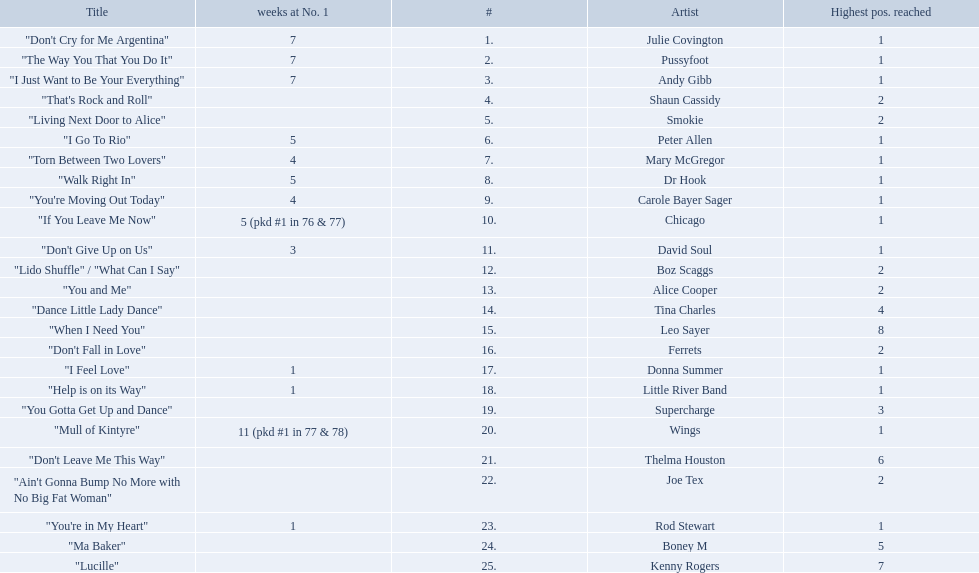Who had the one of the least weeks at number one? Rod Stewart. Parse the full table. {'header': ['Title', 'weeks at No. 1', '#', 'Artist', 'Highest pos. reached'], 'rows': [['"Don\'t Cry for Me Argentina"', '7', '1.', 'Julie Covington', '1'], ['"The Way You That You Do It"', '7', '2.', 'Pussyfoot', '1'], ['"I Just Want to Be Your Everything"', '7', '3.', 'Andy Gibb', '1'], ['"That\'s Rock and Roll"', '', '4.', 'Shaun Cassidy', '2'], ['"Living Next Door to Alice"', '', '5.', 'Smokie', '2'], ['"I Go To Rio"', '5', '6.', 'Peter Allen', '1'], ['"Torn Between Two Lovers"', '4', '7.', 'Mary McGregor', '1'], ['"Walk Right In"', '5', '8.', 'Dr Hook', '1'], ['"You\'re Moving Out Today"', '4', '9.', 'Carole Bayer Sager', '1'], ['"If You Leave Me Now"', '5 (pkd #1 in 76 & 77)', '10.', 'Chicago', '1'], ['"Don\'t Give Up on Us"', '3', '11.', 'David Soul', '1'], ['"Lido Shuffle" / "What Can I Say"', '', '12.', 'Boz Scaggs', '2'], ['"You and Me"', '', '13.', 'Alice Cooper', '2'], ['"Dance Little Lady Dance"', '', '14.', 'Tina Charles', '4'], ['"When I Need You"', '', '15.', 'Leo Sayer', '8'], ['"Don\'t Fall in Love"', '', '16.', 'Ferrets', '2'], ['"I Feel Love"', '1', '17.', 'Donna Summer', '1'], ['"Help is on its Way"', '1', '18.', 'Little River Band', '1'], ['"You Gotta Get Up and Dance"', '', '19.', 'Supercharge', '3'], ['"Mull of Kintyre"', '11 (pkd #1 in 77 & 78)', '20.', 'Wings', '1'], ['"Don\'t Leave Me This Way"', '', '21.', 'Thelma Houston', '6'], ['"Ain\'t Gonna Bump No More with No Big Fat Woman"', '', '22.', 'Joe Tex', '2'], ['"You\'re in My Heart"', '1', '23.', 'Rod Stewart', '1'], ['"Ma Baker"', '', '24.', 'Boney M', '5'], ['"Lucille"', '', '25.', 'Kenny Rogers', '7']]} Who had no week at number one? Shaun Cassidy. Who had the highest number of weeks at number one? Wings. 